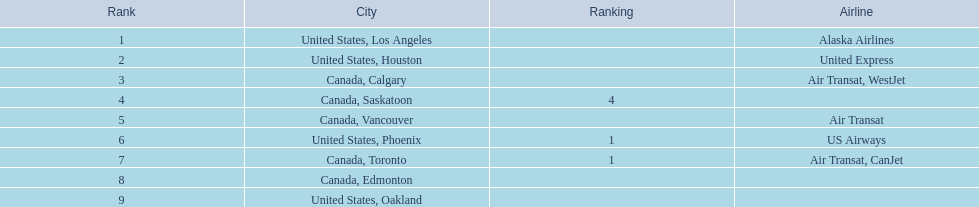What are all the cities? United States, Los Angeles, United States, Houston, Canada, Calgary, Canada, Saskatoon, Canada, Vancouver, United States, Phoenix, Canada, Toronto, Canada, Edmonton, United States, Oakland. How many passengers do they service? 14,749, 5,465, 3,761, 2,282, 2,103, 1,829, 1,202, 110, 107. Which city, when combined with los angeles, totals nearly 19,000? Canada, Calgary. 